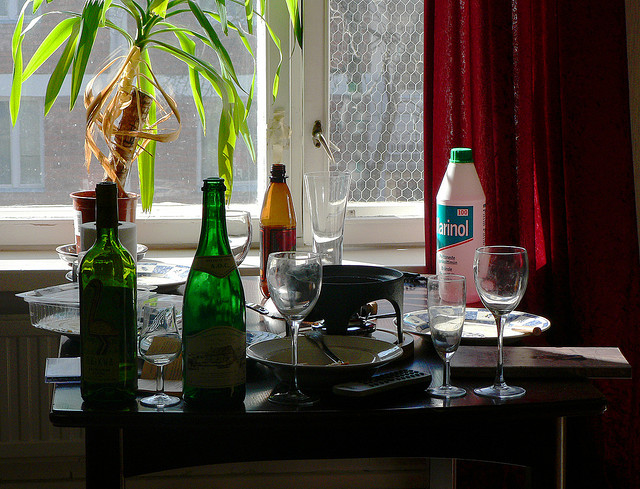Please extract the text content from this image. arinol 100 